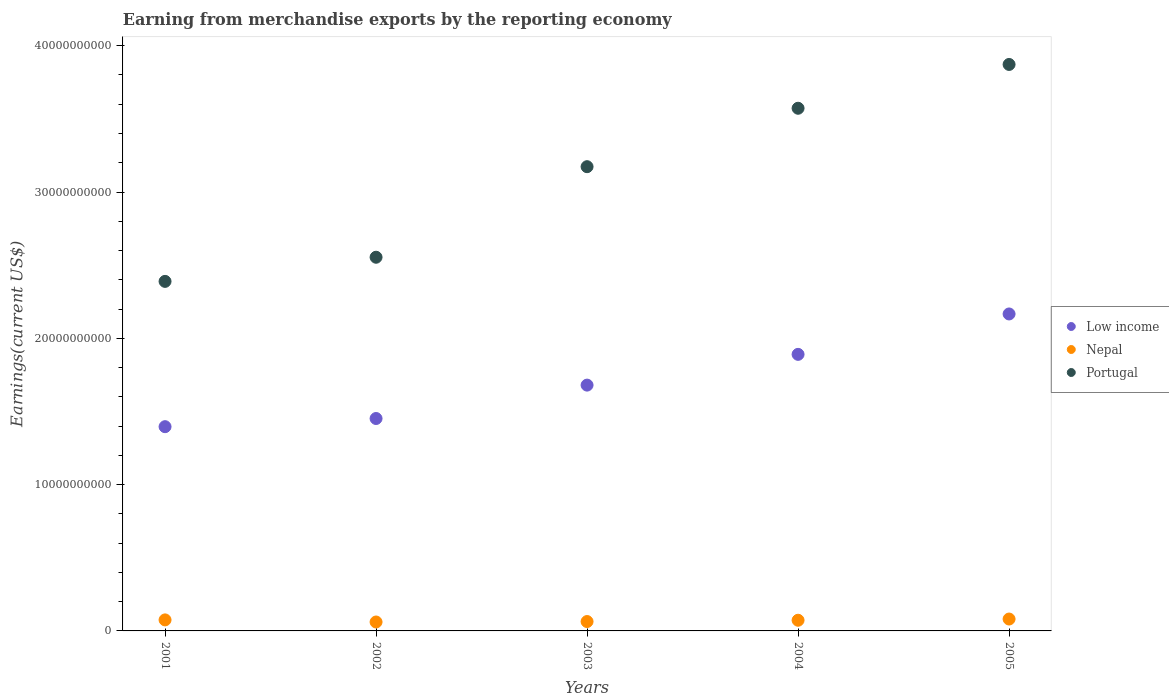How many different coloured dotlines are there?
Your answer should be very brief. 3. What is the amount earned from merchandise exports in Nepal in 2004?
Provide a short and direct response. 7.30e+08. Across all years, what is the maximum amount earned from merchandise exports in Nepal?
Give a very brief answer. 8.13e+08. Across all years, what is the minimum amount earned from merchandise exports in Portugal?
Ensure brevity in your answer.  2.39e+1. In which year was the amount earned from merchandise exports in Nepal maximum?
Make the answer very short. 2005. In which year was the amount earned from merchandise exports in Portugal minimum?
Offer a terse response. 2001. What is the total amount earned from merchandise exports in Nepal in the graph?
Ensure brevity in your answer.  3.55e+09. What is the difference between the amount earned from merchandise exports in Portugal in 2001 and that in 2005?
Provide a succinct answer. -1.48e+1. What is the difference between the amount earned from merchandise exports in Nepal in 2003 and the amount earned from merchandise exports in Portugal in 2005?
Keep it short and to the point. -3.81e+1. What is the average amount earned from merchandise exports in Nepal per year?
Your response must be concise. 7.09e+08. In the year 2004, what is the difference between the amount earned from merchandise exports in Nepal and amount earned from merchandise exports in Low income?
Provide a succinct answer. -1.82e+1. In how many years, is the amount earned from merchandise exports in Portugal greater than 2000000000 US$?
Offer a terse response. 5. What is the ratio of the amount earned from merchandise exports in Low income in 2001 to that in 2003?
Ensure brevity in your answer.  0.83. Is the difference between the amount earned from merchandise exports in Nepal in 2004 and 2005 greater than the difference between the amount earned from merchandise exports in Low income in 2004 and 2005?
Your answer should be very brief. Yes. What is the difference between the highest and the second highest amount earned from merchandise exports in Nepal?
Provide a succinct answer. 5.91e+07. What is the difference between the highest and the lowest amount earned from merchandise exports in Nepal?
Keep it short and to the point. 2.02e+08. Is the sum of the amount earned from merchandise exports in Low income in 2001 and 2002 greater than the maximum amount earned from merchandise exports in Nepal across all years?
Give a very brief answer. Yes. Is it the case that in every year, the sum of the amount earned from merchandise exports in Portugal and amount earned from merchandise exports in Low income  is greater than the amount earned from merchandise exports in Nepal?
Offer a terse response. Yes. How many dotlines are there?
Ensure brevity in your answer.  3. Where does the legend appear in the graph?
Your answer should be very brief. Center right. How are the legend labels stacked?
Your response must be concise. Vertical. What is the title of the graph?
Ensure brevity in your answer.  Earning from merchandise exports by the reporting economy. Does "Namibia" appear as one of the legend labels in the graph?
Offer a very short reply. No. What is the label or title of the X-axis?
Provide a succinct answer. Years. What is the label or title of the Y-axis?
Your response must be concise. Earnings(current US$). What is the Earnings(current US$) in Low income in 2001?
Offer a terse response. 1.40e+1. What is the Earnings(current US$) of Nepal in 2001?
Your answer should be compact. 7.54e+08. What is the Earnings(current US$) in Portugal in 2001?
Make the answer very short. 2.39e+1. What is the Earnings(current US$) of Low income in 2002?
Offer a terse response. 1.45e+1. What is the Earnings(current US$) in Nepal in 2002?
Your response must be concise. 6.10e+08. What is the Earnings(current US$) in Portugal in 2002?
Give a very brief answer. 2.55e+1. What is the Earnings(current US$) of Low income in 2003?
Provide a short and direct response. 1.68e+1. What is the Earnings(current US$) in Nepal in 2003?
Your answer should be very brief. 6.41e+08. What is the Earnings(current US$) in Portugal in 2003?
Ensure brevity in your answer.  3.17e+1. What is the Earnings(current US$) in Low income in 2004?
Offer a terse response. 1.89e+1. What is the Earnings(current US$) of Nepal in 2004?
Keep it short and to the point. 7.30e+08. What is the Earnings(current US$) of Portugal in 2004?
Your response must be concise. 3.57e+1. What is the Earnings(current US$) of Low income in 2005?
Keep it short and to the point. 2.17e+1. What is the Earnings(current US$) of Nepal in 2005?
Make the answer very short. 8.13e+08. What is the Earnings(current US$) in Portugal in 2005?
Provide a succinct answer. 3.87e+1. Across all years, what is the maximum Earnings(current US$) of Low income?
Ensure brevity in your answer.  2.17e+1. Across all years, what is the maximum Earnings(current US$) in Nepal?
Provide a succinct answer. 8.13e+08. Across all years, what is the maximum Earnings(current US$) in Portugal?
Offer a very short reply. 3.87e+1. Across all years, what is the minimum Earnings(current US$) in Low income?
Offer a terse response. 1.40e+1. Across all years, what is the minimum Earnings(current US$) of Nepal?
Ensure brevity in your answer.  6.10e+08. Across all years, what is the minimum Earnings(current US$) in Portugal?
Provide a short and direct response. 2.39e+1. What is the total Earnings(current US$) of Low income in the graph?
Your answer should be very brief. 8.59e+1. What is the total Earnings(current US$) of Nepal in the graph?
Keep it short and to the point. 3.55e+09. What is the total Earnings(current US$) of Portugal in the graph?
Your answer should be compact. 1.56e+11. What is the difference between the Earnings(current US$) of Low income in 2001 and that in 2002?
Provide a short and direct response. -5.59e+08. What is the difference between the Earnings(current US$) of Nepal in 2001 and that in 2002?
Keep it short and to the point. 1.43e+08. What is the difference between the Earnings(current US$) of Portugal in 2001 and that in 2002?
Offer a terse response. -1.65e+09. What is the difference between the Earnings(current US$) of Low income in 2001 and that in 2003?
Provide a short and direct response. -2.84e+09. What is the difference between the Earnings(current US$) in Nepal in 2001 and that in 2003?
Offer a terse response. 1.12e+08. What is the difference between the Earnings(current US$) of Portugal in 2001 and that in 2003?
Offer a terse response. -7.84e+09. What is the difference between the Earnings(current US$) in Low income in 2001 and that in 2004?
Provide a succinct answer. -4.94e+09. What is the difference between the Earnings(current US$) of Nepal in 2001 and that in 2004?
Your answer should be very brief. 2.40e+07. What is the difference between the Earnings(current US$) of Portugal in 2001 and that in 2004?
Make the answer very short. -1.18e+1. What is the difference between the Earnings(current US$) in Low income in 2001 and that in 2005?
Provide a short and direct response. -7.70e+09. What is the difference between the Earnings(current US$) of Nepal in 2001 and that in 2005?
Offer a very short reply. -5.91e+07. What is the difference between the Earnings(current US$) in Portugal in 2001 and that in 2005?
Provide a succinct answer. -1.48e+1. What is the difference between the Earnings(current US$) in Low income in 2002 and that in 2003?
Keep it short and to the point. -2.28e+09. What is the difference between the Earnings(current US$) of Nepal in 2002 and that in 2003?
Your answer should be compact. -3.09e+07. What is the difference between the Earnings(current US$) of Portugal in 2002 and that in 2003?
Provide a succinct answer. -6.19e+09. What is the difference between the Earnings(current US$) in Low income in 2002 and that in 2004?
Keep it short and to the point. -4.38e+09. What is the difference between the Earnings(current US$) of Nepal in 2002 and that in 2004?
Give a very brief answer. -1.19e+08. What is the difference between the Earnings(current US$) in Portugal in 2002 and that in 2004?
Your answer should be compact. -1.02e+1. What is the difference between the Earnings(current US$) of Low income in 2002 and that in 2005?
Your response must be concise. -7.15e+09. What is the difference between the Earnings(current US$) of Nepal in 2002 and that in 2005?
Your answer should be very brief. -2.02e+08. What is the difference between the Earnings(current US$) of Portugal in 2002 and that in 2005?
Give a very brief answer. -1.32e+1. What is the difference between the Earnings(current US$) of Low income in 2003 and that in 2004?
Offer a very short reply. -2.10e+09. What is the difference between the Earnings(current US$) of Nepal in 2003 and that in 2004?
Your answer should be very brief. -8.83e+07. What is the difference between the Earnings(current US$) in Portugal in 2003 and that in 2004?
Your answer should be compact. -3.99e+09. What is the difference between the Earnings(current US$) in Low income in 2003 and that in 2005?
Give a very brief answer. -4.86e+09. What is the difference between the Earnings(current US$) in Nepal in 2003 and that in 2005?
Offer a terse response. -1.71e+08. What is the difference between the Earnings(current US$) in Portugal in 2003 and that in 2005?
Your answer should be compact. -6.99e+09. What is the difference between the Earnings(current US$) of Low income in 2004 and that in 2005?
Provide a succinct answer. -2.76e+09. What is the difference between the Earnings(current US$) in Nepal in 2004 and that in 2005?
Your answer should be very brief. -8.31e+07. What is the difference between the Earnings(current US$) in Portugal in 2004 and that in 2005?
Your answer should be very brief. -2.99e+09. What is the difference between the Earnings(current US$) of Low income in 2001 and the Earnings(current US$) of Nepal in 2002?
Your answer should be very brief. 1.34e+1. What is the difference between the Earnings(current US$) in Low income in 2001 and the Earnings(current US$) in Portugal in 2002?
Ensure brevity in your answer.  -1.16e+1. What is the difference between the Earnings(current US$) of Nepal in 2001 and the Earnings(current US$) of Portugal in 2002?
Your answer should be very brief. -2.48e+1. What is the difference between the Earnings(current US$) of Low income in 2001 and the Earnings(current US$) of Nepal in 2003?
Offer a terse response. 1.33e+1. What is the difference between the Earnings(current US$) of Low income in 2001 and the Earnings(current US$) of Portugal in 2003?
Offer a very short reply. -1.78e+1. What is the difference between the Earnings(current US$) of Nepal in 2001 and the Earnings(current US$) of Portugal in 2003?
Provide a short and direct response. -3.10e+1. What is the difference between the Earnings(current US$) in Low income in 2001 and the Earnings(current US$) in Nepal in 2004?
Your answer should be compact. 1.32e+1. What is the difference between the Earnings(current US$) in Low income in 2001 and the Earnings(current US$) in Portugal in 2004?
Provide a succinct answer. -2.18e+1. What is the difference between the Earnings(current US$) in Nepal in 2001 and the Earnings(current US$) in Portugal in 2004?
Your response must be concise. -3.50e+1. What is the difference between the Earnings(current US$) in Low income in 2001 and the Earnings(current US$) in Nepal in 2005?
Your answer should be very brief. 1.31e+1. What is the difference between the Earnings(current US$) in Low income in 2001 and the Earnings(current US$) in Portugal in 2005?
Provide a short and direct response. -2.48e+1. What is the difference between the Earnings(current US$) in Nepal in 2001 and the Earnings(current US$) in Portugal in 2005?
Provide a short and direct response. -3.80e+1. What is the difference between the Earnings(current US$) of Low income in 2002 and the Earnings(current US$) of Nepal in 2003?
Give a very brief answer. 1.39e+1. What is the difference between the Earnings(current US$) of Low income in 2002 and the Earnings(current US$) of Portugal in 2003?
Offer a very short reply. -1.72e+1. What is the difference between the Earnings(current US$) of Nepal in 2002 and the Earnings(current US$) of Portugal in 2003?
Give a very brief answer. -3.11e+1. What is the difference between the Earnings(current US$) of Low income in 2002 and the Earnings(current US$) of Nepal in 2004?
Your answer should be very brief. 1.38e+1. What is the difference between the Earnings(current US$) of Low income in 2002 and the Earnings(current US$) of Portugal in 2004?
Your answer should be compact. -2.12e+1. What is the difference between the Earnings(current US$) of Nepal in 2002 and the Earnings(current US$) of Portugal in 2004?
Keep it short and to the point. -3.51e+1. What is the difference between the Earnings(current US$) in Low income in 2002 and the Earnings(current US$) in Nepal in 2005?
Give a very brief answer. 1.37e+1. What is the difference between the Earnings(current US$) of Low income in 2002 and the Earnings(current US$) of Portugal in 2005?
Offer a very short reply. -2.42e+1. What is the difference between the Earnings(current US$) of Nepal in 2002 and the Earnings(current US$) of Portugal in 2005?
Your answer should be very brief. -3.81e+1. What is the difference between the Earnings(current US$) of Low income in 2003 and the Earnings(current US$) of Nepal in 2004?
Your answer should be very brief. 1.61e+1. What is the difference between the Earnings(current US$) of Low income in 2003 and the Earnings(current US$) of Portugal in 2004?
Provide a succinct answer. -1.89e+1. What is the difference between the Earnings(current US$) in Nepal in 2003 and the Earnings(current US$) in Portugal in 2004?
Provide a short and direct response. -3.51e+1. What is the difference between the Earnings(current US$) in Low income in 2003 and the Earnings(current US$) in Nepal in 2005?
Your answer should be very brief. 1.60e+1. What is the difference between the Earnings(current US$) in Low income in 2003 and the Earnings(current US$) in Portugal in 2005?
Give a very brief answer. -2.19e+1. What is the difference between the Earnings(current US$) of Nepal in 2003 and the Earnings(current US$) of Portugal in 2005?
Give a very brief answer. -3.81e+1. What is the difference between the Earnings(current US$) in Low income in 2004 and the Earnings(current US$) in Nepal in 2005?
Your answer should be compact. 1.81e+1. What is the difference between the Earnings(current US$) in Low income in 2004 and the Earnings(current US$) in Portugal in 2005?
Provide a succinct answer. -1.98e+1. What is the difference between the Earnings(current US$) in Nepal in 2004 and the Earnings(current US$) in Portugal in 2005?
Offer a very short reply. -3.80e+1. What is the average Earnings(current US$) of Low income per year?
Keep it short and to the point. 1.72e+1. What is the average Earnings(current US$) in Nepal per year?
Provide a short and direct response. 7.09e+08. What is the average Earnings(current US$) in Portugal per year?
Offer a very short reply. 3.11e+1. In the year 2001, what is the difference between the Earnings(current US$) in Low income and Earnings(current US$) in Nepal?
Offer a very short reply. 1.32e+1. In the year 2001, what is the difference between the Earnings(current US$) in Low income and Earnings(current US$) in Portugal?
Provide a short and direct response. -9.93e+09. In the year 2001, what is the difference between the Earnings(current US$) of Nepal and Earnings(current US$) of Portugal?
Keep it short and to the point. -2.31e+1. In the year 2002, what is the difference between the Earnings(current US$) in Low income and Earnings(current US$) in Nepal?
Ensure brevity in your answer.  1.39e+1. In the year 2002, what is the difference between the Earnings(current US$) of Low income and Earnings(current US$) of Portugal?
Your answer should be very brief. -1.10e+1. In the year 2002, what is the difference between the Earnings(current US$) in Nepal and Earnings(current US$) in Portugal?
Give a very brief answer. -2.49e+1. In the year 2003, what is the difference between the Earnings(current US$) of Low income and Earnings(current US$) of Nepal?
Offer a terse response. 1.62e+1. In the year 2003, what is the difference between the Earnings(current US$) in Low income and Earnings(current US$) in Portugal?
Make the answer very short. -1.49e+1. In the year 2003, what is the difference between the Earnings(current US$) in Nepal and Earnings(current US$) in Portugal?
Offer a terse response. -3.11e+1. In the year 2004, what is the difference between the Earnings(current US$) in Low income and Earnings(current US$) in Nepal?
Offer a very short reply. 1.82e+1. In the year 2004, what is the difference between the Earnings(current US$) in Low income and Earnings(current US$) in Portugal?
Give a very brief answer. -1.68e+1. In the year 2004, what is the difference between the Earnings(current US$) in Nepal and Earnings(current US$) in Portugal?
Keep it short and to the point. -3.50e+1. In the year 2005, what is the difference between the Earnings(current US$) in Low income and Earnings(current US$) in Nepal?
Give a very brief answer. 2.09e+1. In the year 2005, what is the difference between the Earnings(current US$) of Low income and Earnings(current US$) of Portugal?
Offer a terse response. -1.71e+1. In the year 2005, what is the difference between the Earnings(current US$) of Nepal and Earnings(current US$) of Portugal?
Offer a very short reply. -3.79e+1. What is the ratio of the Earnings(current US$) in Low income in 2001 to that in 2002?
Provide a succinct answer. 0.96. What is the ratio of the Earnings(current US$) of Nepal in 2001 to that in 2002?
Give a very brief answer. 1.23. What is the ratio of the Earnings(current US$) of Portugal in 2001 to that in 2002?
Offer a terse response. 0.94. What is the ratio of the Earnings(current US$) in Low income in 2001 to that in 2003?
Give a very brief answer. 0.83. What is the ratio of the Earnings(current US$) of Nepal in 2001 to that in 2003?
Provide a short and direct response. 1.18. What is the ratio of the Earnings(current US$) in Portugal in 2001 to that in 2003?
Your response must be concise. 0.75. What is the ratio of the Earnings(current US$) in Low income in 2001 to that in 2004?
Offer a terse response. 0.74. What is the ratio of the Earnings(current US$) of Nepal in 2001 to that in 2004?
Provide a succinct answer. 1.03. What is the ratio of the Earnings(current US$) in Portugal in 2001 to that in 2004?
Give a very brief answer. 0.67. What is the ratio of the Earnings(current US$) of Low income in 2001 to that in 2005?
Your response must be concise. 0.64. What is the ratio of the Earnings(current US$) of Nepal in 2001 to that in 2005?
Offer a terse response. 0.93. What is the ratio of the Earnings(current US$) in Portugal in 2001 to that in 2005?
Provide a succinct answer. 0.62. What is the ratio of the Earnings(current US$) in Low income in 2002 to that in 2003?
Your response must be concise. 0.86. What is the ratio of the Earnings(current US$) of Nepal in 2002 to that in 2003?
Give a very brief answer. 0.95. What is the ratio of the Earnings(current US$) of Portugal in 2002 to that in 2003?
Your response must be concise. 0.8. What is the ratio of the Earnings(current US$) of Low income in 2002 to that in 2004?
Your answer should be compact. 0.77. What is the ratio of the Earnings(current US$) in Nepal in 2002 to that in 2004?
Offer a terse response. 0.84. What is the ratio of the Earnings(current US$) in Portugal in 2002 to that in 2004?
Your response must be concise. 0.71. What is the ratio of the Earnings(current US$) of Low income in 2002 to that in 2005?
Your response must be concise. 0.67. What is the ratio of the Earnings(current US$) of Nepal in 2002 to that in 2005?
Your response must be concise. 0.75. What is the ratio of the Earnings(current US$) in Portugal in 2002 to that in 2005?
Your response must be concise. 0.66. What is the ratio of the Earnings(current US$) of Low income in 2003 to that in 2004?
Offer a very short reply. 0.89. What is the ratio of the Earnings(current US$) in Nepal in 2003 to that in 2004?
Offer a very short reply. 0.88. What is the ratio of the Earnings(current US$) of Portugal in 2003 to that in 2004?
Provide a short and direct response. 0.89. What is the ratio of the Earnings(current US$) in Low income in 2003 to that in 2005?
Give a very brief answer. 0.78. What is the ratio of the Earnings(current US$) in Nepal in 2003 to that in 2005?
Your response must be concise. 0.79. What is the ratio of the Earnings(current US$) of Portugal in 2003 to that in 2005?
Ensure brevity in your answer.  0.82. What is the ratio of the Earnings(current US$) of Low income in 2004 to that in 2005?
Make the answer very short. 0.87. What is the ratio of the Earnings(current US$) in Nepal in 2004 to that in 2005?
Make the answer very short. 0.9. What is the ratio of the Earnings(current US$) in Portugal in 2004 to that in 2005?
Offer a very short reply. 0.92. What is the difference between the highest and the second highest Earnings(current US$) in Low income?
Your response must be concise. 2.76e+09. What is the difference between the highest and the second highest Earnings(current US$) of Nepal?
Give a very brief answer. 5.91e+07. What is the difference between the highest and the second highest Earnings(current US$) of Portugal?
Keep it short and to the point. 2.99e+09. What is the difference between the highest and the lowest Earnings(current US$) of Low income?
Your answer should be very brief. 7.70e+09. What is the difference between the highest and the lowest Earnings(current US$) in Nepal?
Ensure brevity in your answer.  2.02e+08. What is the difference between the highest and the lowest Earnings(current US$) of Portugal?
Keep it short and to the point. 1.48e+1. 